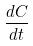<formula> <loc_0><loc_0><loc_500><loc_500>\frac { d C } { d t }</formula> 